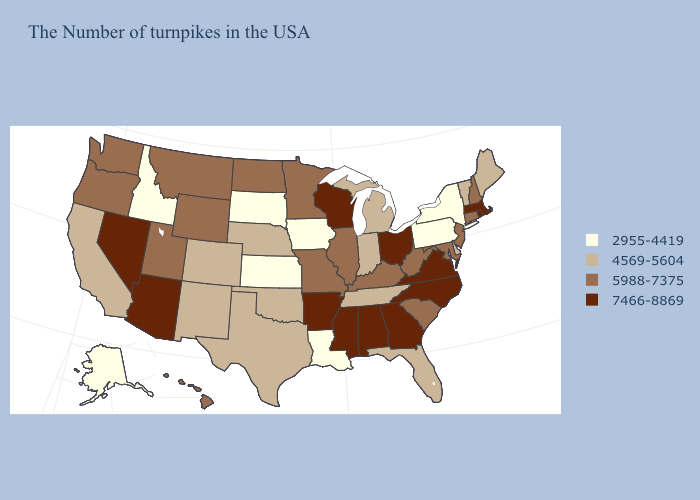Name the states that have a value in the range 2955-4419?
Write a very short answer. New York, Pennsylvania, Louisiana, Iowa, Kansas, South Dakota, Idaho, Alaska. Name the states that have a value in the range 7466-8869?
Keep it brief. Massachusetts, Rhode Island, Virginia, North Carolina, Ohio, Georgia, Alabama, Wisconsin, Mississippi, Arkansas, Arizona, Nevada. Name the states that have a value in the range 5988-7375?
Answer briefly. New Hampshire, Connecticut, New Jersey, Maryland, South Carolina, West Virginia, Kentucky, Illinois, Missouri, Minnesota, North Dakota, Wyoming, Utah, Montana, Washington, Oregon, Hawaii. Which states have the lowest value in the USA?
Be succinct. New York, Pennsylvania, Louisiana, Iowa, Kansas, South Dakota, Idaho, Alaska. Name the states that have a value in the range 5988-7375?
Answer briefly. New Hampshire, Connecticut, New Jersey, Maryland, South Carolina, West Virginia, Kentucky, Illinois, Missouri, Minnesota, North Dakota, Wyoming, Utah, Montana, Washington, Oregon, Hawaii. Does South Dakota have the same value as Illinois?
Be succinct. No. Does New York have a higher value than Florida?
Concise answer only. No. Does South Carolina have the lowest value in the South?
Short answer required. No. Name the states that have a value in the range 2955-4419?
Keep it brief. New York, Pennsylvania, Louisiana, Iowa, Kansas, South Dakota, Idaho, Alaska. What is the lowest value in states that border New Hampshire?
Write a very short answer. 4569-5604. Name the states that have a value in the range 2955-4419?
Concise answer only. New York, Pennsylvania, Louisiana, Iowa, Kansas, South Dakota, Idaho, Alaska. What is the value of Connecticut?
Quick response, please. 5988-7375. Which states have the lowest value in the USA?
Be succinct. New York, Pennsylvania, Louisiana, Iowa, Kansas, South Dakota, Idaho, Alaska. Among the states that border Virginia , which have the lowest value?
Concise answer only. Tennessee. What is the highest value in states that border Alabama?
Short answer required. 7466-8869. 